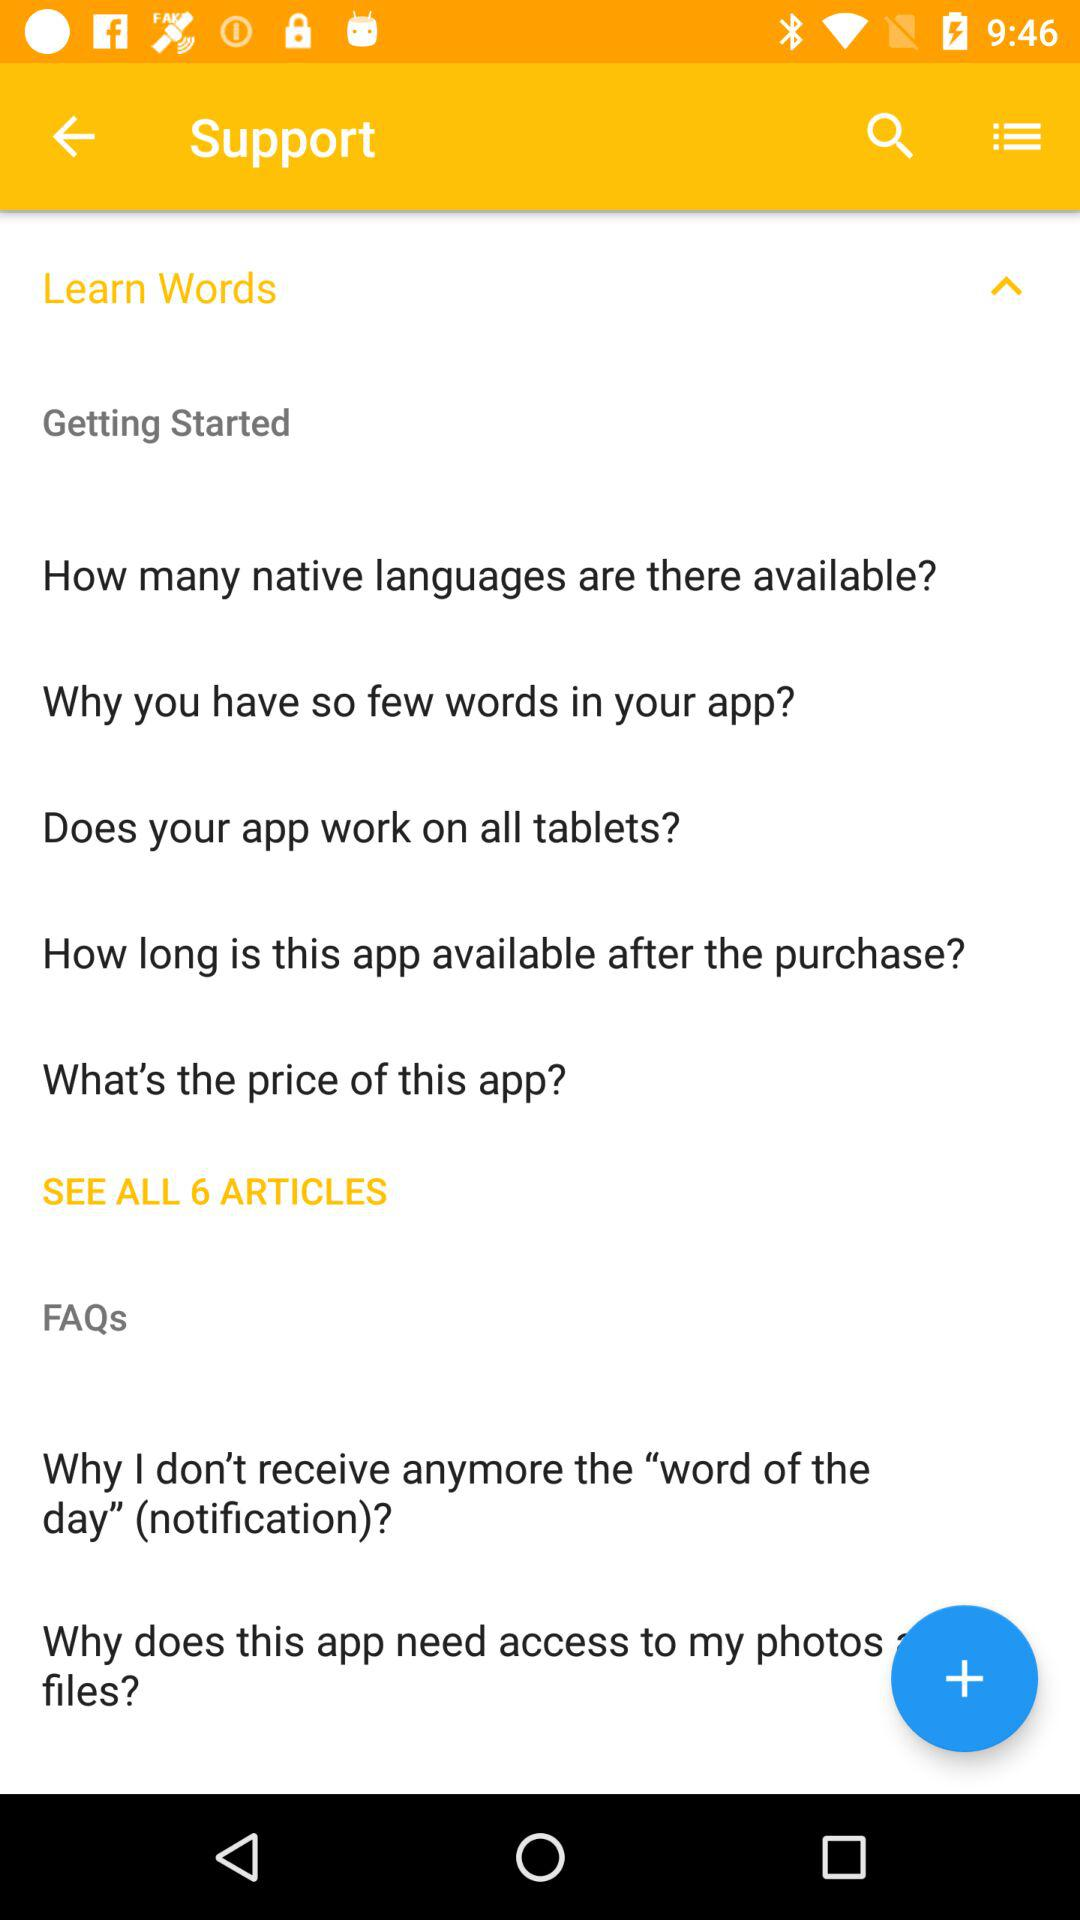How many articles are there in total? There are 6 articles in total. 